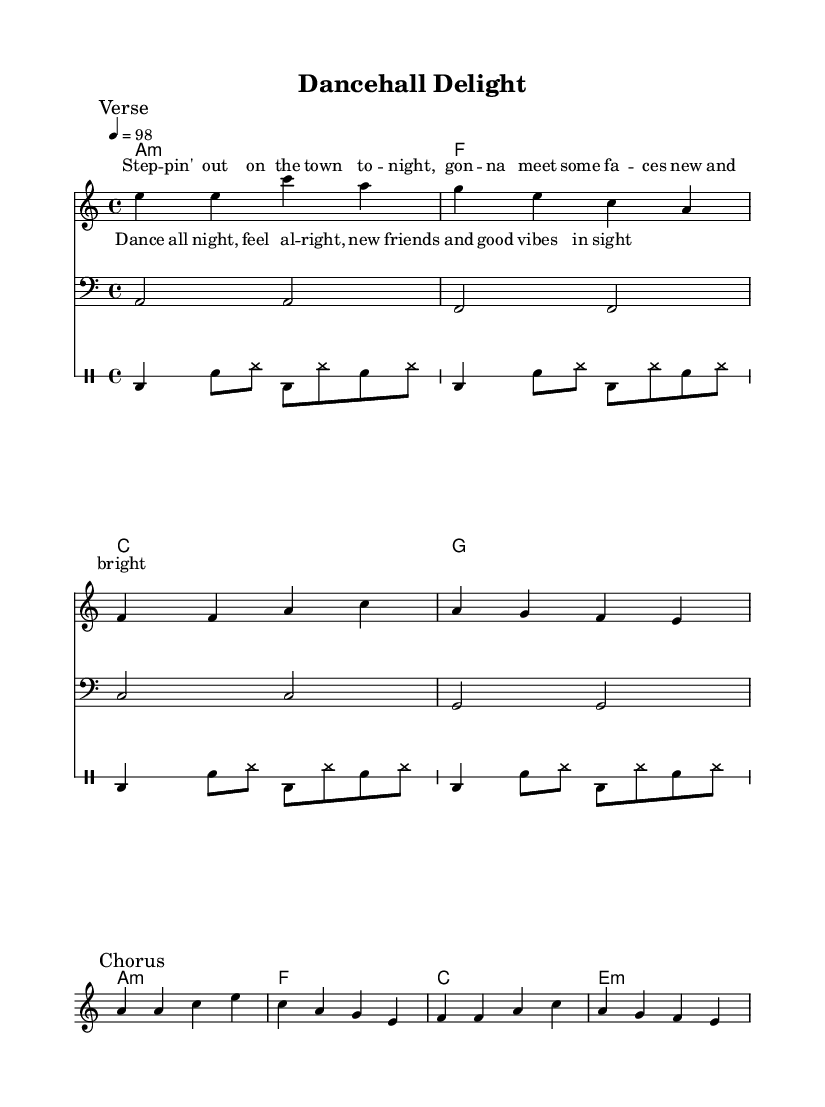What is the key signature of this music? The key signature is indicated at the beginning of the score. It shows one flat (B♭) representing the key of A minor.
Answer: A minor What is the time signature? The time signature is located at the start of the music sheet indicating how many beats are in each measure. Here, it is 4/4, which means there are four beats in each measure.
Answer: 4/4 What is the tempo marking in this piece? The tempo marking appears next to the global section and indicates the speed of the piece. It states "4 = 98," meaning there are 98 beats per minute.
Answer: 98 How many measures are in the verse section? By analyzing the melody in the verse marked section, I can count a total of four measures.
Answer: 4 What type of drum is denoted by 'bd'? In the drum notation, 'bd' stands for bass drum, which is commonly used in reggae music to give it a solid foundation.
Answer: Bass drum What are the main themes expressed in the lyrics? The lyrics convey themes of socializing, meeting new people, and enjoying good vibes, highlighting the carefree spirit often present in reggae music.
Answer: Joy of socializing What elements make this music a Reggae-funk fusion? The music incorporates rhythmic bass lines typical in funk along with the offbeat guitar strumming and drum patterns characteristic of reggae, creating a blend of both genres.
Answer: Rhythmic bass lines and offbeat strumming 